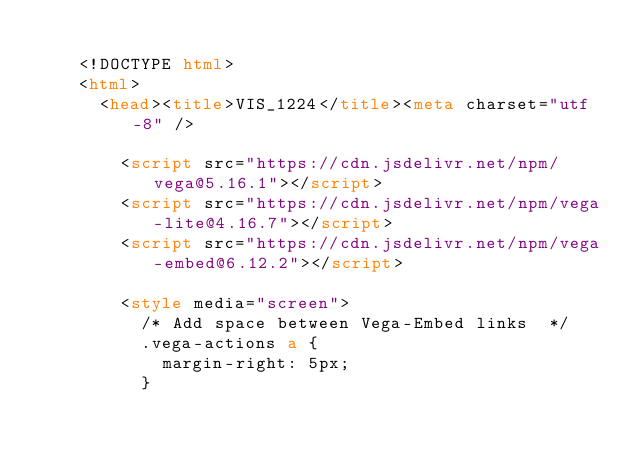<code> <loc_0><loc_0><loc_500><loc_500><_HTML_>
    <!DOCTYPE html>
    <html>
      <head><title>VIS_1224</title><meta charset="utf-8" />

        <script src="https://cdn.jsdelivr.net/npm/vega@5.16.1"></script>
        <script src="https://cdn.jsdelivr.net/npm/vega-lite@4.16.7"></script>
        <script src="https://cdn.jsdelivr.net/npm/vega-embed@6.12.2"></script>

        <style media="screen">
          /* Add space between Vega-Embed links  */
          .vega-actions a {
            margin-right: 5px;
          }
</code> 